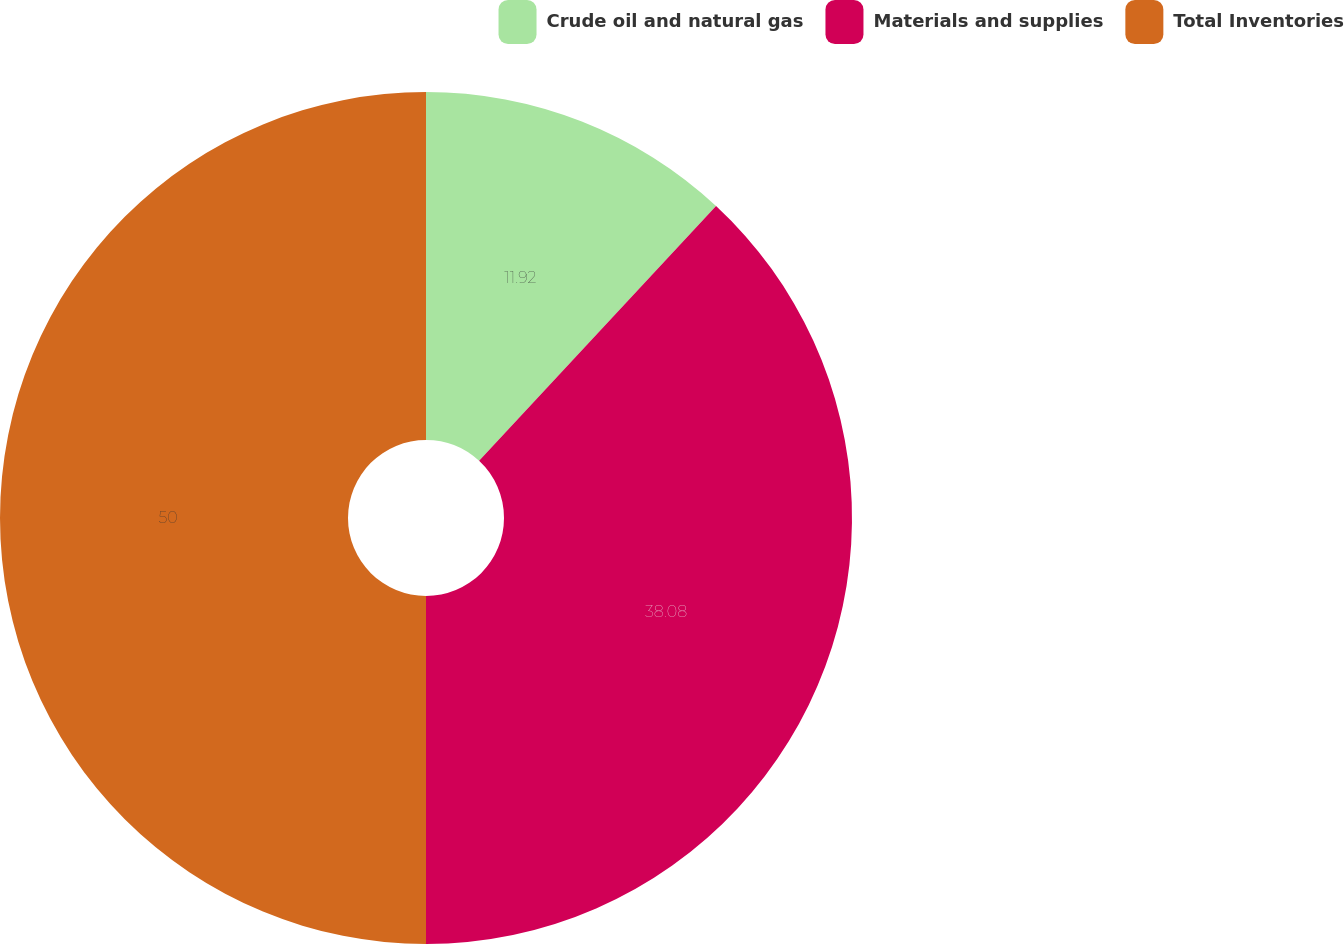Convert chart to OTSL. <chart><loc_0><loc_0><loc_500><loc_500><pie_chart><fcel>Crude oil and natural gas<fcel>Materials and supplies<fcel>Total Inventories<nl><fcel>11.92%<fcel>38.08%<fcel>50.0%<nl></chart> 